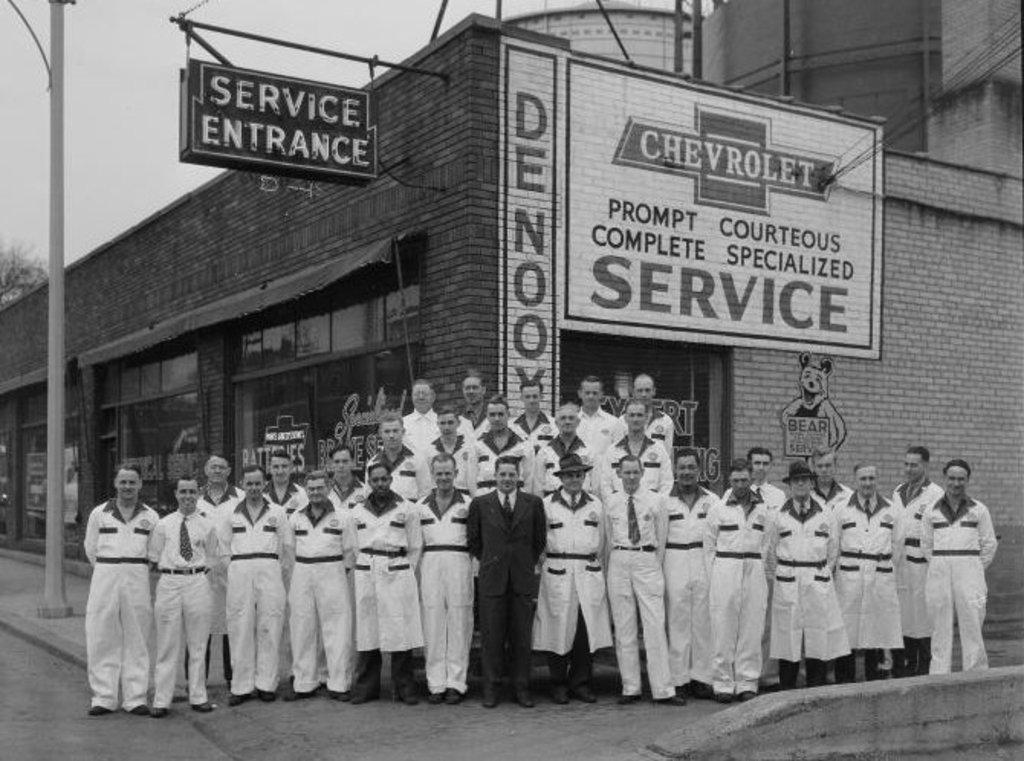What is the color scheme of the image? The image is black and white. What can be seen on the floor in the image? There are persons standing on the floor in the image. What type of establishments are present in the image? There are stores in the image. What is on the wall in the image? There is an advertisement on a wall in the image. What other signage is present in the image? There is a sign board and a name board in the image. What architectural features are visible in the image? There are poles in the image. What part of the natural environment is visible in the image? The sky is visible in the image. What type of coastline can be seen in the image? There is no coastline visible in the image; it features a black and white scene with people, stores, and signage. Where is the lunchroom located in the image? There is no lunchroom present in the image. 